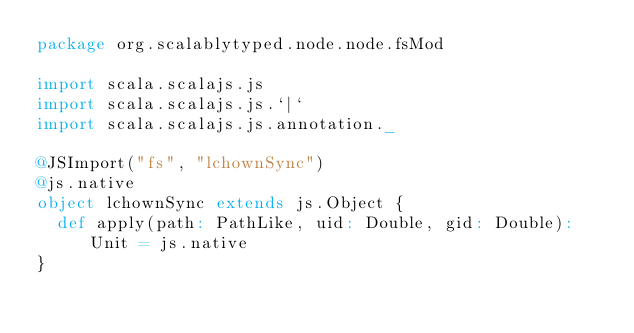Convert code to text. <code><loc_0><loc_0><loc_500><loc_500><_Scala_>package org.scalablytyped.node.node.fsMod

import scala.scalajs.js
import scala.scalajs.js.`|`
import scala.scalajs.js.annotation._

@JSImport("fs", "lchownSync")
@js.native
object lchownSync extends js.Object {
  def apply(path: PathLike, uid: Double, gid: Double): Unit = js.native
}

</code> 